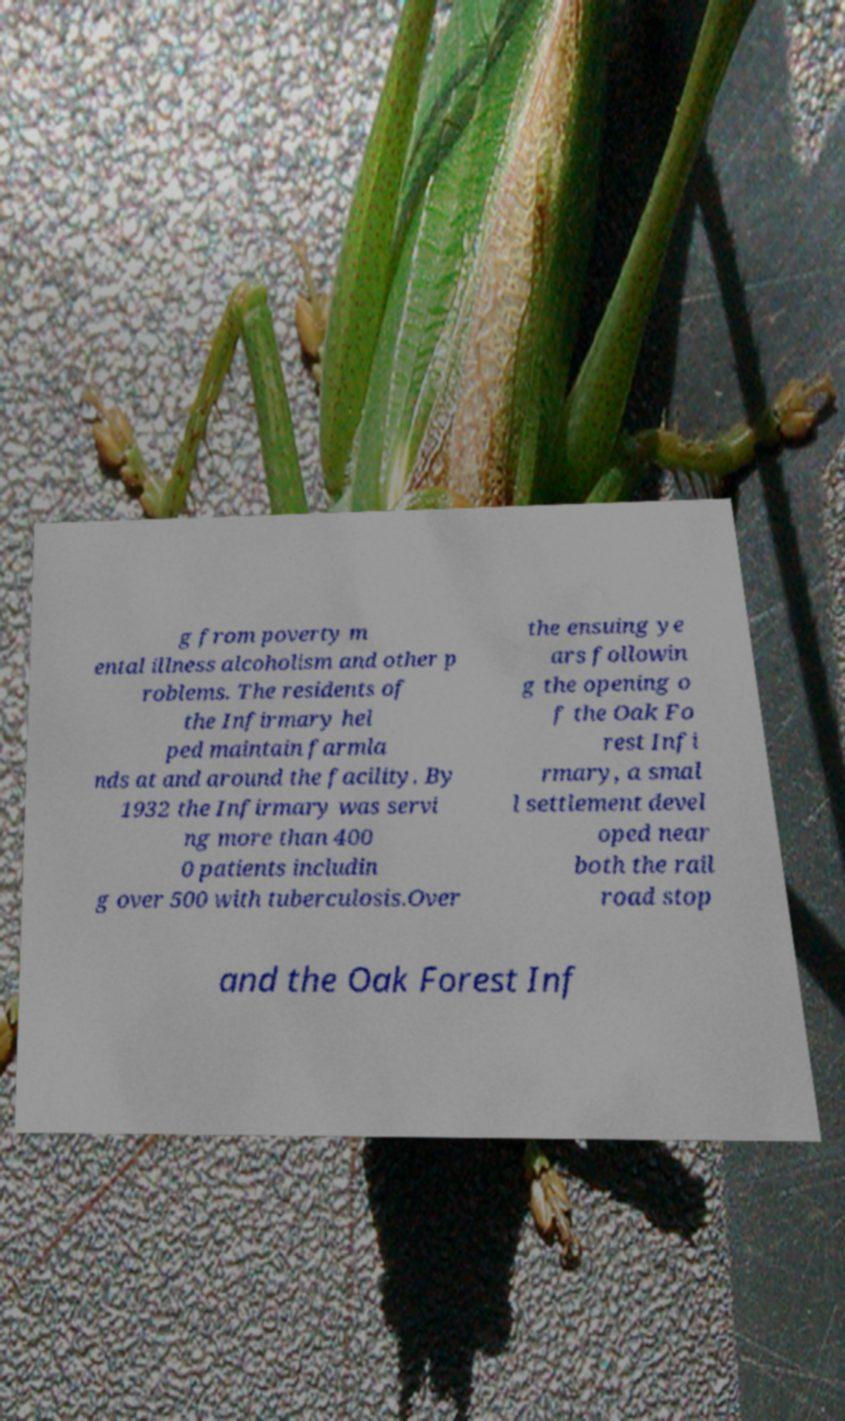Please read and relay the text visible in this image. What does it say? g from poverty m ental illness alcoholism and other p roblems. The residents of the Infirmary hel ped maintain farmla nds at and around the facility. By 1932 the Infirmary was servi ng more than 400 0 patients includin g over 500 with tuberculosis.Over the ensuing ye ars followin g the opening o f the Oak Fo rest Infi rmary, a smal l settlement devel oped near both the rail road stop and the Oak Forest Inf 